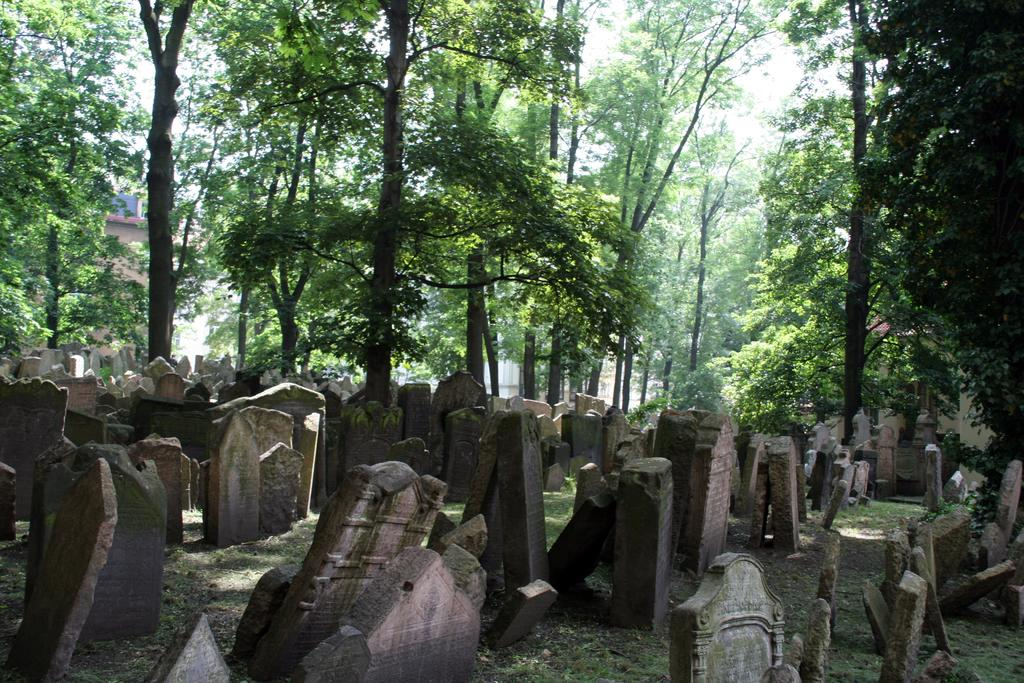What type of location is depicted in the image? The image shows cemeteries. What can be seen in the background of the image? There are trees and the sky visible in the background of the image. What is the color of the trees in the image? The trees are green in color. What is the color of the sky in the image? The sky is white in color. What type of notebook is being used to write on the trees in the image? There is no notebook present in the image, and the trees are not being written on. 